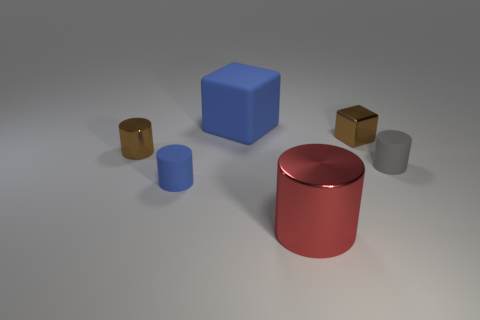Subtract 1 cylinders. How many cylinders are left? 3 Add 3 big purple metal balls. How many objects exist? 9 Subtract all blocks. How many objects are left? 4 Subtract all big metallic objects. Subtract all cylinders. How many objects are left? 1 Add 2 metallic cylinders. How many metallic cylinders are left? 4 Add 2 tiny metal balls. How many tiny metal balls exist? 2 Subtract 1 brown cubes. How many objects are left? 5 